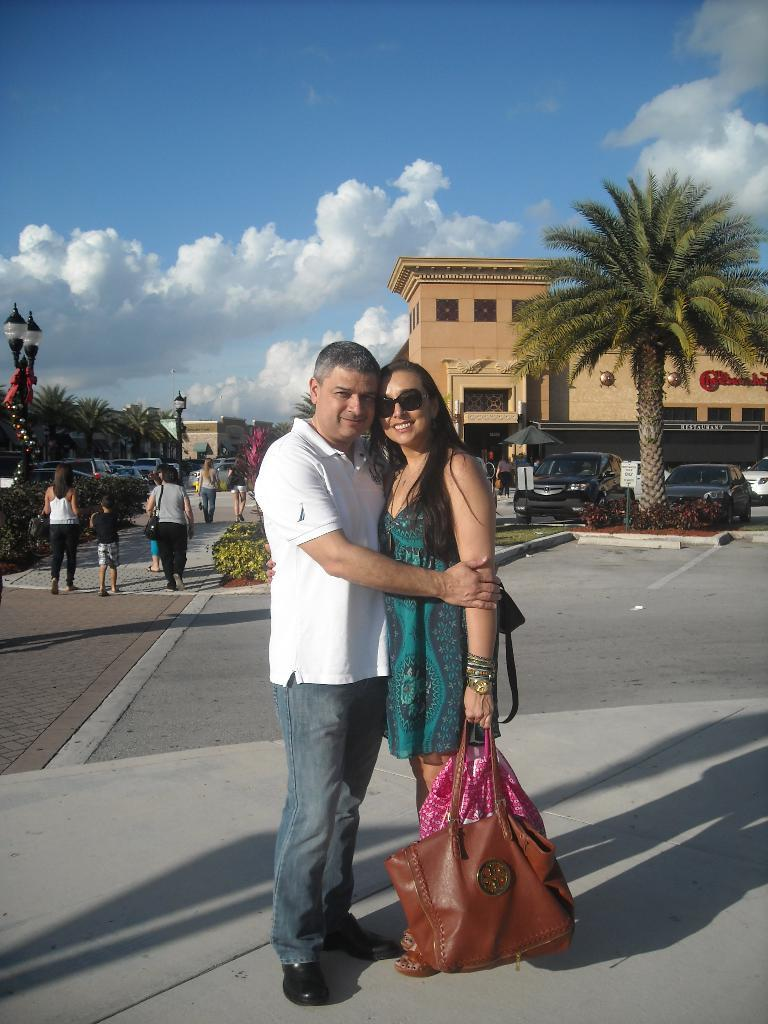What is the person in the image wearing? The person is wearing a white shirt in the image. What is the person doing in the image? The person is hugging a woman. What is the woman carrying in the image? The woman is carrying a brown bag. What can be seen in the background of the image? There are buildings, trees, and cars in the background of the image. What is the color of the sky in the image? The sky is blue in color. What type of thread is being used to sew the crib in the image? A: There is no crib present in the image, so it is not possible to determine what type of thread is being used. 